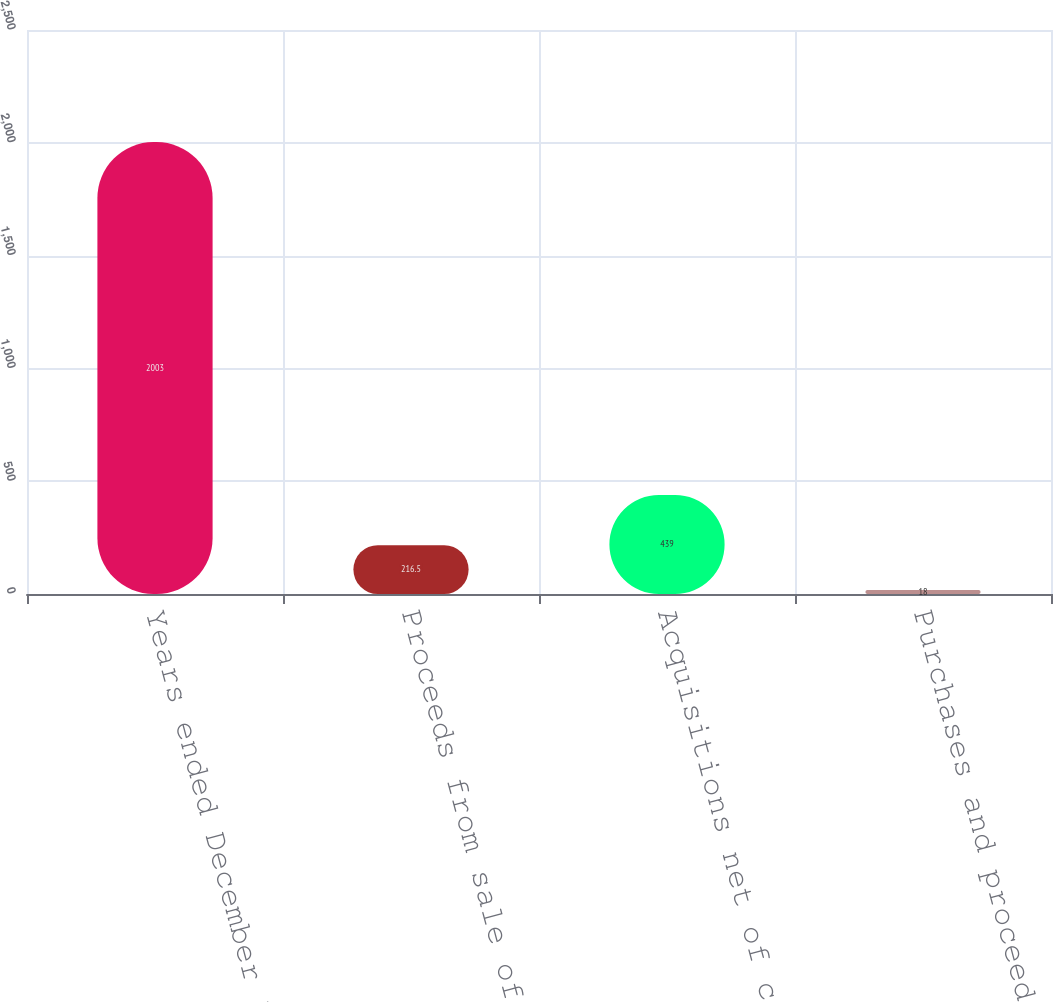<chart> <loc_0><loc_0><loc_500><loc_500><bar_chart><fcel>Years ended December 31<fcel>Proceeds from sale of PP&E and<fcel>Acquisitions net of cash<fcel>Purchases and proceeds from<nl><fcel>2003<fcel>216.5<fcel>439<fcel>18<nl></chart> 